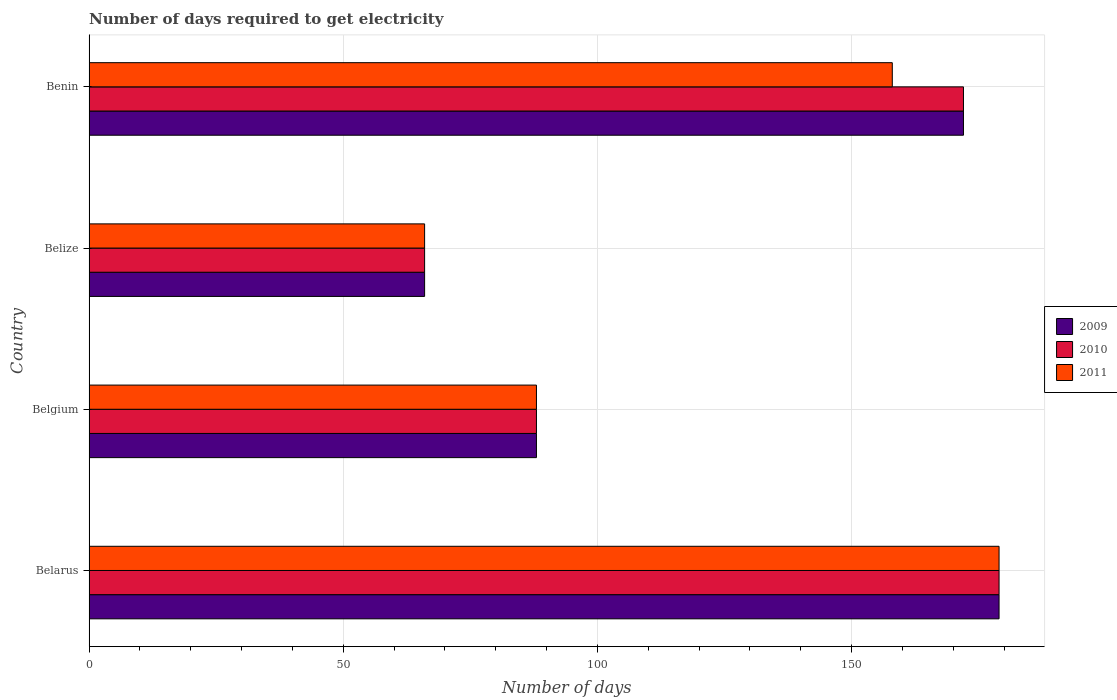How many groups of bars are there?
Offer a very short reply. 4. Are the number of bars per tick equal to the number of legend labels?
Your answer should be compact. Yes. Are the number of bars on each tick of the Y-axis equal?
Offer a very short reply. Yes. How many bars are there on the 3rd tick from the top?
Offer a terse response. 3. What is the label of the 1st group of bars from the top?
Provide a short and direct response. Benin. In how many cases, is the number of bars for a given country not equal to the number of legend labels?
Your answer should be very brief. 0. What is the number of days required to get electricity in in 2009 in Benin?
Your answer should be compact. 172. Across all countries, what is the maximum number of days required to get electricity in in 2011?
Your answer should be very brief. 179. In which country was the number of days required to get electricity in in 2009 maximum?
Ensure brevity in your answer.  Belarus. In which country was the number of days required to get electricity in in 2010 minimum?
Offer a terse response. Belize. What is the total number of days required to get electricity in in 2009 in the graph?
Your answer should be very brief. 505. What is the difference between the number of days required to get electricity in in 2010 in Belarus and that in Belgium?
Your answer should be compact. 91. What is the average number of days required to get electricity in in 2009 per country?
Make the answer very short. 126.25. What is the difference between the number of days required to get electricity in in 2011 and number of days required to get electricity in in 2009 in Belize?
Provide a short and direct response. 0. What is the ratio of the number of days required to get electricity in in 2011 in Belgium to that in Benin?
Make the answer very short. 0.56. Is the difference between the number of days required to get electricity in in 2011 in Belarus and Benin greater than the difference between the number of days required to get electricity in in 2009 in Belarus and Benin?
Provide a short and direct response. Yes. What is the difference between the highest and the lowest number of days required to get electricity in in 2009?
Make the answer very short. 113. Is the sum of the number of days required to get electricity in in 2010 in Belarus and Benin greater than the maximum number of days required to get electricity in in 2011 across all countries?
Give a very brief answer. Yes. What does the 1st bar from the top in Belize represents?
Make the answer very short. 2011. What does the 3rd bar from the bottom in Benin represents?
Keep it short and to the point. 2011. Is it the case that in every country, the sum of the number of days required to get electricity in in 2011 and number of days required to get electricity in in 2010 is greater than the number of days required to get electricity in in 2009?
Offer a very short reply. Yes. How many bars are there?
Make the answer very short. 12. What is the difference between two consecutive major ticks on the X-axis?
Provide a short and direct response. 50. Are the values on the major ticks of X-axis written in scientific E-notation?
Provide a short and direct response. No. Where does the legend appear in the graph?
Ensure brevity in your answer.  Center right. How are the legend labels stacked?
Ensure brevity in your answer.  Vertical. What is the title of the graph?
Your answer should be very brief. Number of days required to get electricity. Does "1973" appear as one of the legend labels in the graph?
Keep it short and to the point. No. What is the label or title of the X-axis?
Your answer should be compact. Number of days. What is the Number of days of 2009 in Belarus?
Keep it short and to the point. 179. What is the Number of days of 2010 in Belarus?
Offer a terse response. 179. What is the Number of days of 2011 in Belarus?
Give a very brief answer. 179. What is the Number of days of 2009 in Belgium?
Offer a terse response. 88. What is the Number of days of 2009 in Belize?
Keep it short and to the point. 66. What is the Number of days in 2009 in Benin?
Make the answer very short. 172. What is the Number of days in 2010 in Benin?
Keep it short and to the point. 172. What is the Number of days in 2011 in Benin?
Your answer should be compact. 158. Across all countries, what is the maximum Number of days of 2009?
Ensure brevity in your answer.  179. Across all countries, what is the maximum Number of days of 2010?
Keep it short and to the point. 179. Across all countries, what is the maximum Number of days in 2011?
Your response must be concise. 179. Across all countries, what is the minimum Number of days of 2011?
Your answer should be compact. 66. What is the total Number of days of 2009 in the graph?
Your answer should be compact. 505. What is the total Number of days of 2010 in the graph?
Provide a succinct answer. 505. What is the total Number of days of 2011 in the graph?
Your answer should be compact. 491. What is the difference between the Number of days of 2009 in Belarus and that in Belgium?
Your response must be concise. 91. What is the difference between the Number of days of 2010 in Belarus and that in Belgium?
Provide a succinct answer. 91. What is the difference between the Number of days in 2011 in Belarus and that in Belgium?
Make the answer very short. 91. What is the difference between the Number of days in 2009 in Belarus and that in Belize?
Make the answer very short. 113. What is the difference between the Number of days of 2010 in Belarus and that in Belize?
Provide a short and direct response. 113. What is the difference between the Number of days in 2011 in Belarus and that in Belize?
Keep it short and to the point. 113. What is the difference between the Number of days of 2011 in Belarus and that in Benin?
Provide a short and direct response. 21. What is the difference between the Number of days of 2009 in Belgium and that in Belize?
Make the answer very short. 22. What is the difference between the Number of days of 2010 in Belgium and that in Belize?
Provide a succinct answer. 22. What is the difference between the Number of days of 2009 in Belgium and that in Benin?
Make the answer very short. -84. What is the difference between the Number of days of 2010 in Belgium and that in Benin?
Provide a short and direct response. -84. What is the difference between the Number of days of 2011 in Belgium and that in Benin?
Make the answer very short. -70. What is the difference between the Number of days of 2009 in Belize and that in Benin?
Provide a short and direct response. -106. What is the difference between the Number of days of 2010 in Belize and that in Benin?
Provide a short and direct response. -106. What is the difference between the Number of days in 2011 in Belize and that in Benin?
Ensure brevity in your answer.  -92. What is the difference between the Number of days in 2009 in Belarus and the Number of days in 2010 in Belgium?
Your response must be concise. 91. What is the difference between the Number of days of 2009 in Belarus and the Number of days of 2011 in Belgium?
Your answer should be compact. 91. What is the difference between the Number of days in 2010 in Belarus and the Number of days in 2011 in Belgium?
Your response must be concise. 91. What is the difference between the Number of days of 2009 in Belarus and the Number of days of 2010 in Belize?
Your response must be concise. 113. What is the difference between the Number of days of 2009 in Belarus and the Number of days of 2011 in Belize?
Your answer should be very brief. 113. What is the difference between the Number of days in 2010 in Belarus and the Number of days in 2011 in Belize?
Ensure brevity in your answer.  113. What is the difference between the Number of days of 2009 in Belgium and the Number of days of 2010 in Benin?
Make the answer very short. -84. What is the difference between the Number of days of 2009 in Belgium and the Number of days of 2011 in Benin?
Your answer should be compact. -70. What is the difference between the Number of days of 2010 in Belgium and the Number of days of 2011 in Benin?
Your response must be concise. -70. What is the difference between the Number of days in 2009 in Belize and the Number of days in 2010 in Benin?
Give a very brief answer. -106. What is the difference between the Number of days of 2009 in Belize and the Number of days of 2011 in Benin?
Offer a terse response. -92. What is the difference between the Number of days in 2010 in Belize and the Number of days in 2011 in Benin?
Your answer should be compact. -92. What is the average Number of days of 2009 per country?
Ensure brevity in your answer.  126.25. What is the average Number of days in 2010 per country?
Make the answer very short. 126.25. What is the average Number of days of 2011 per country?
Your response must be concise. 122.75. What is the difference between the Number of days in 2009 and Number of days in 2011 in Belarus?
Your answer should be very brief. 0. What is the difference between the Number of days of 2010 and Number of days of 2011 in Belarus?
Keep it short and to the point. 0. What is the difference between the Number of days in 2009 and Number of days in 2010 in Belgium?
Give a very brief answer. 0. What is the difference between the Number of days in 2010 and Number of days in 2011 in Belgium?
Offer a terse response. 0. What is the difference between the Number of days in 2009 and Number of days in 2010 in Belize?
Your answer should be compact. 0. What is the difference between the Number of days in 2009 and Number of days in 2011 in Belize?
Give a very brief answer. 0. What is the difference between the Number of days in 2009 and Number of days in 2011 in Benin?
Provide a short and direct response. 14. What is the ratio of the Number of days of 2009 in Belarus to that in Belgium?
Make the answer very short. 2.03. What is the ratio of the Number of days of 2010 in Belarus to that in Belgium?
Ensure brevity in your answer.  2.03. What is the ratio of the Number of days in 2011 in Belarus to that in Belgium?
Ensure brevity in your answer.  2.03. What is the ratio of the Number of days of 2009 in Belarus to that in Belize?
Your response must be concise. 2.71. What is the ratio of the Number of days in 2010 in Belarus to that in Belize?
Ensure brevity in your answer.  2.71. What is the ratio of the Number of days of 2011 in Belarus to that in Belize?
Your answer should be compact. 2.71. What is the ratio of the Number of days in 2009 in Belarus to that in Benin?
Offer a terse response. 1.04. What is the ratio of the Number of days of 2010 in Belarus to that in Benin?
Give a very brief answer. 1.04. What is the ratio of the Number of days of 2011 in Belarus to that in Benin?
Make the answer very short. 1.13. What is the ratio of the Number of days of 2009 in Belgium to that in Belize?
Your answer should be very brief. 1.33. What is the ratio of the Number of days of 2009 in Belgium to that in Benin?
Offer a very short reply. 0.51. What is the ratio of the Number of days of 2010 in Belgium to that in Benin?
Provide a succinct answer. 0.51. What is the ratio of the Number of days of 2011 in Belgium to that in Benin?
Your answer should be very brief. 0.56. What is the ratio of the Number of days in 2009 in Belize to that in Benin?
Give a very brief answer. 0.38. What is the ratio of the Number of days of 2010 in Belize to that in Benin?
Provide a succinct answer. 0.38. What is the ratio of the Number of days of 2011 in Belize to that in Benin?
Your response must be concise. 0.42. What is the difference between the highest and the second highest Number of days of 2009?
Offer a very short reply. 7. What is the difference between the highest and the second highest Number of days of 2010?
Offer a very short reply. 7. What is the difference between the highest and the lowest Number of days in 2009?
Provide a short and direct response. 113. What is the difference between the highest and the lowest Number of days of 2010?
Give a very brief answer. 113. What is the difference between the highest and the lowest Number of days in 2011?
Offer a very short reply. 113. 